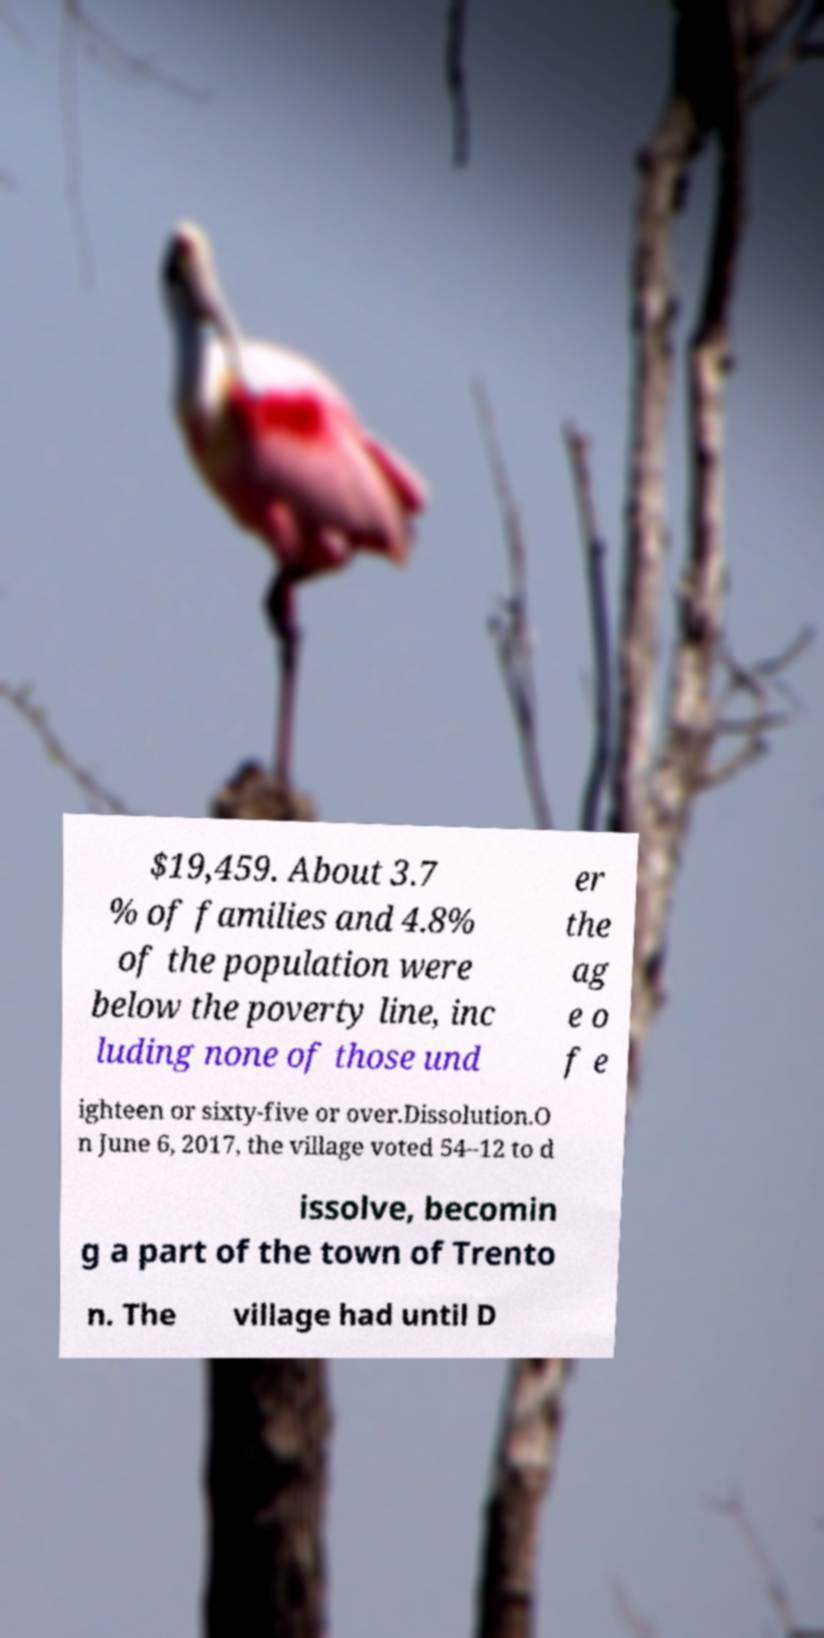Please identify and transcribe the text found in this image. $19,459. About 3.7 % of families and 4.8% of the population were below the poverty line, inc luding none of those und er the ag e o f e ighteen or sixty-five or over.Dissolution.O n June 6, 2017, the village voted 54–12 to d issolve, becomin g a part of the town of Trento n. The village had until D 